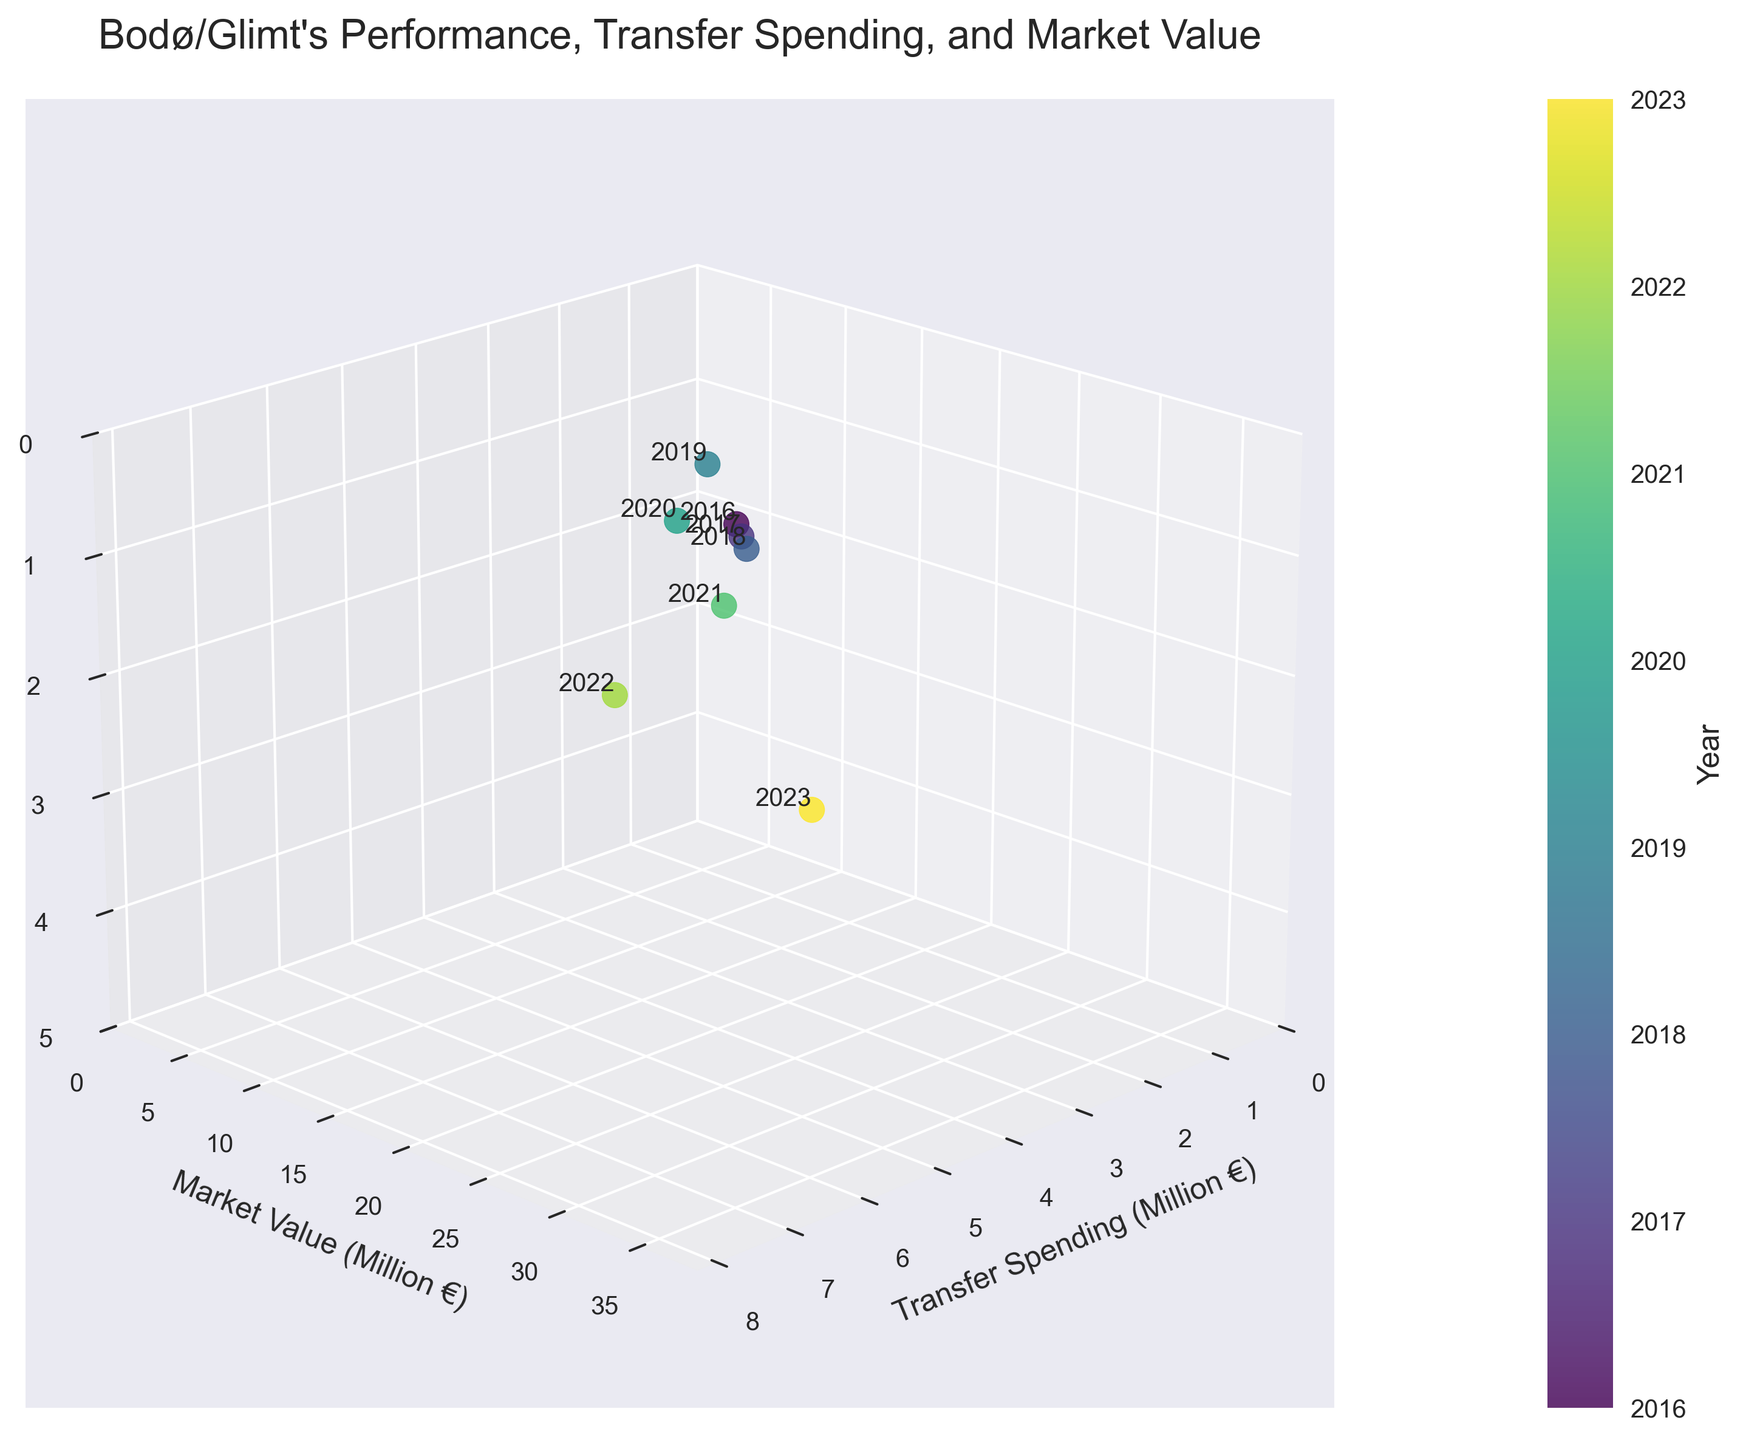How many data points are there in the plot? By counting the number of text labels representing the years, we can see there are 8 data points, corresponding to the years 2016 through 2023.
Answer: 8 What is the title of the plot? The title is displayed at the top of the plot. It reads "Bodø/Glimt's Performance, Transfer Spending, and Market Value".
Answer: Bodø/Glimt's Performance, Transfer Spending, and Market Value How does the transfer spending of Bodø/Glimt change over the years? By examining the x-axis and the changing colors of the data points from 2016 to 2023, we see that transfer spending increases each year.
Answer: Increases What is the transfer spending level in 2021, and how does it compare to 2020? By looking at the x-axis values and the year labels, in 2020 the transfer spending is 3.5 million euros, and in 2021 it rises to 5 million euros. The value increases from 2020 to 2021.
Answer: 5 million euros; increases Which year had the highest market value, and what was the league position that year? The highest point on the y-axis corresponds to the highest market value, which is 2023, with a value of 35 million euros. In that year, the league position (z-axis) is 2.
Answer: 2023; 2 In which year did Bodø/Glimt first achieve the 1st position in the league? By checking the z-axis and the corresponding years, 2019 is the first year Bodø/Glimt achieved the 1st position.
Answer: 2019 What is the difference in market value between 2020 and 2022? From the y-axis, the market value in 2020 is 15 million euros, and in 2022 it is 30 million euros. The difference is 30 - 15 = 15 million euros.
Answer: 15 million euros Does the plot show any correlation between transfer spending and league position over the years? As the transfer spending (x-axis) increases, the league position (z-axis) generally improves, indicating a negative correlation (since the z-axis is inverted).
Answer: Yes, negative correlation How does market value in 2018 compare to 2016 and 2017? The market value in 2018 is 8 million euros, while in 2016 it is 5 million euros, and in 2017 it is 6.5 million euros, showing a steady increase.
Answer: Higher Which years had a league position of 1 for Bodø/Glimt? By identifying the data points where the z-axis value is 1, the years are 2019, 2020, 2021, and 2022.
Answer: 2019, 2020, 2021, 2022 